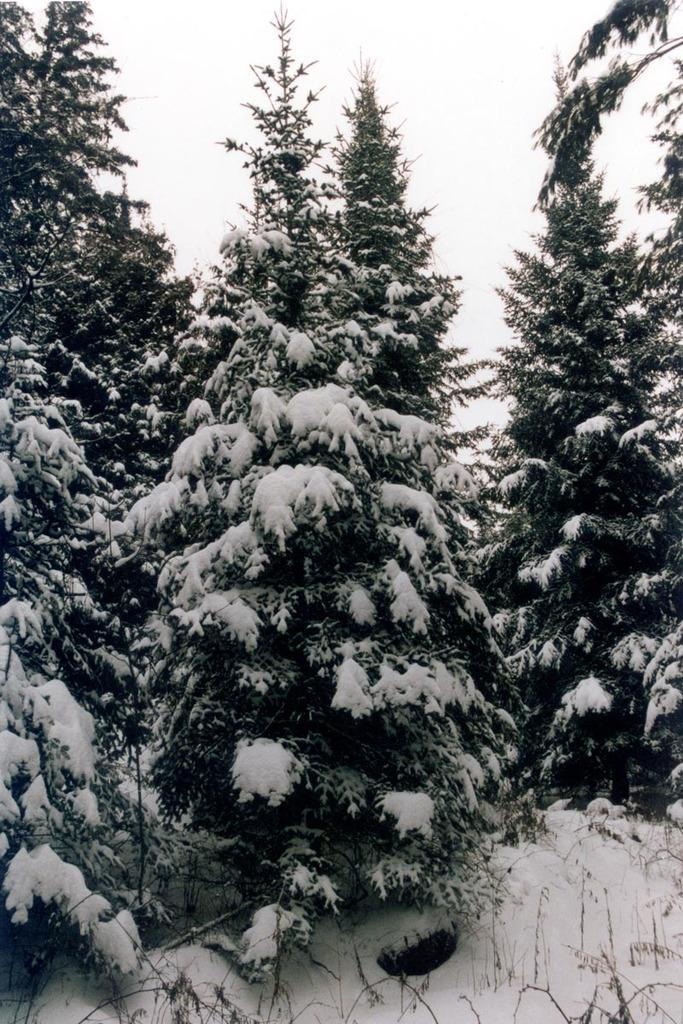What type of vegetation can be seen in the image? There are trees in the image. What is the ground covered with in the image? There is snow visible in the image. What color is the sky in the image? The sky is white in color. Can you see a zebra playing the drum in the image? No, there is no zebra or drum present in the image. Is there a spy hiding behind the trees in the image? No, there is no indication of a spy or any hidden figures in the image. 